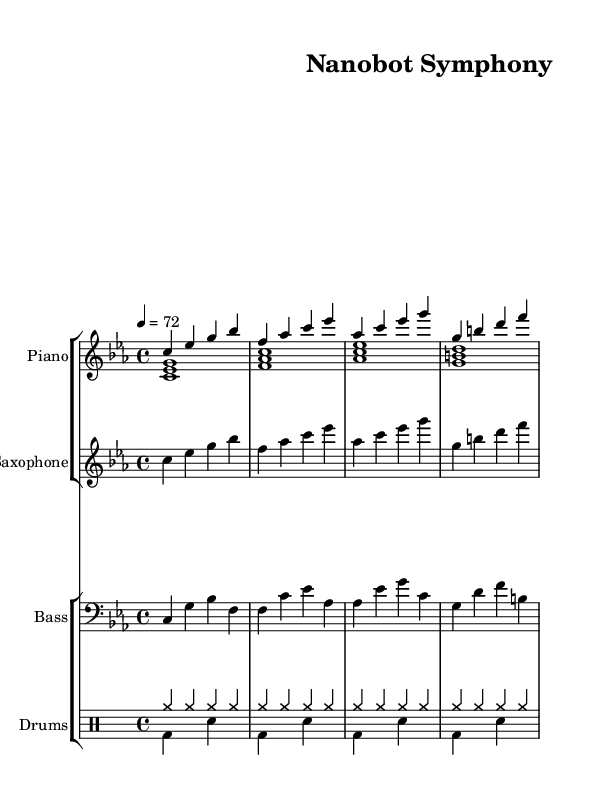What is the key signature of this music? The key signature is C minor, which has three flats (B flat, E flat, and A flat). This is indicated by the "c" in the key signature at the beginning of the score.
Answer: C minor What is the time signature of this music? The time signature is 4/4, which indicates that there are four beats per measure and the quarter note gets one beat. This is shown at the beginning of the score next to the key signature.
Answer: 4/4 What is the tempo marking of this piece? The tempo marking is 72 beats per minute, indicated by the tempo indication "4 = 72" placed at the beginning of the score. It suggests a moderate pace for the performance.
Answer: 72 Which instrument plays the melody in this composition? The saxophone primarily carries the melody, which can be identified as it plays the main melodic lines with clear pitches identical to the right hand of the piano.
Answer: Saxophone How many measures are there in total? The total number of measures can be counted by observing the end of each four-beat grouping presented in the score. There are eight measures shown across the respective staves.
Answer: 8 What type of jazz does this piece resemble based on its structure? The composition resembles smooth jazz, characterized by its laid-back rhythm, gentle melodies, and harmonic richness typical of the smooth jazz genre. This can be inferred from the soft dynamics and chord progression present in the sheet music.
Answer: Smooth jazz 